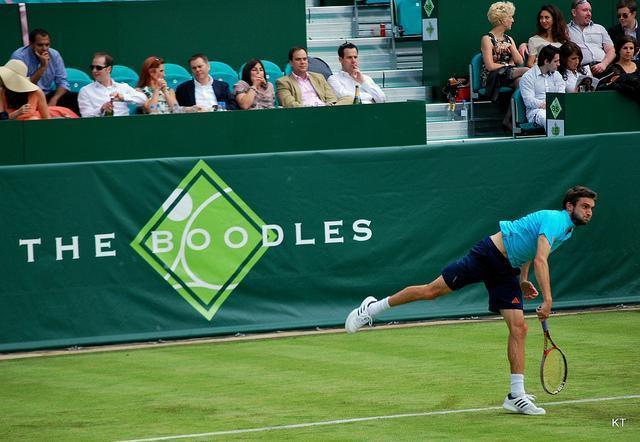How many feet is the man standing on?
Give a very brief answer. 1. How many people are there?
Give a very brief answer. 9. 